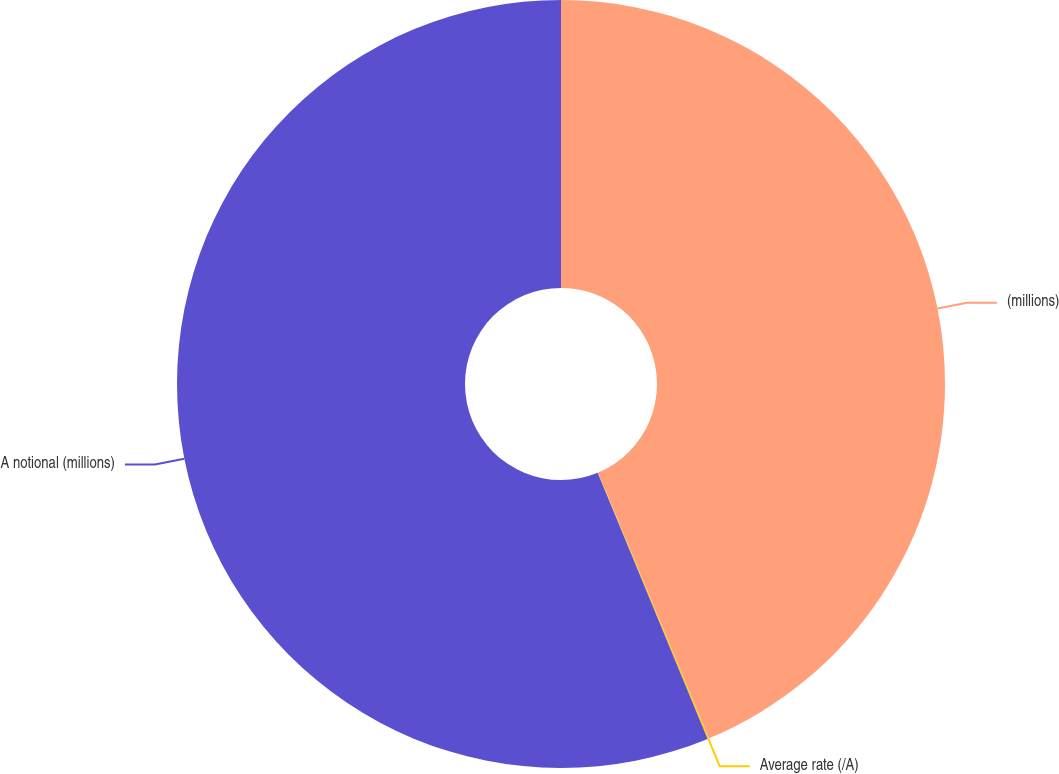Convert chart to OTSL. <chart><loc_0><loc_0><loc_500><loc_500><pie_chart><fcel>(millions)<fcel>Average rate (/A)<fcel>A notional (millions)<nl><fcel>43.71%<fcel>0.06%<fcel>56.24%<nl></chart> 